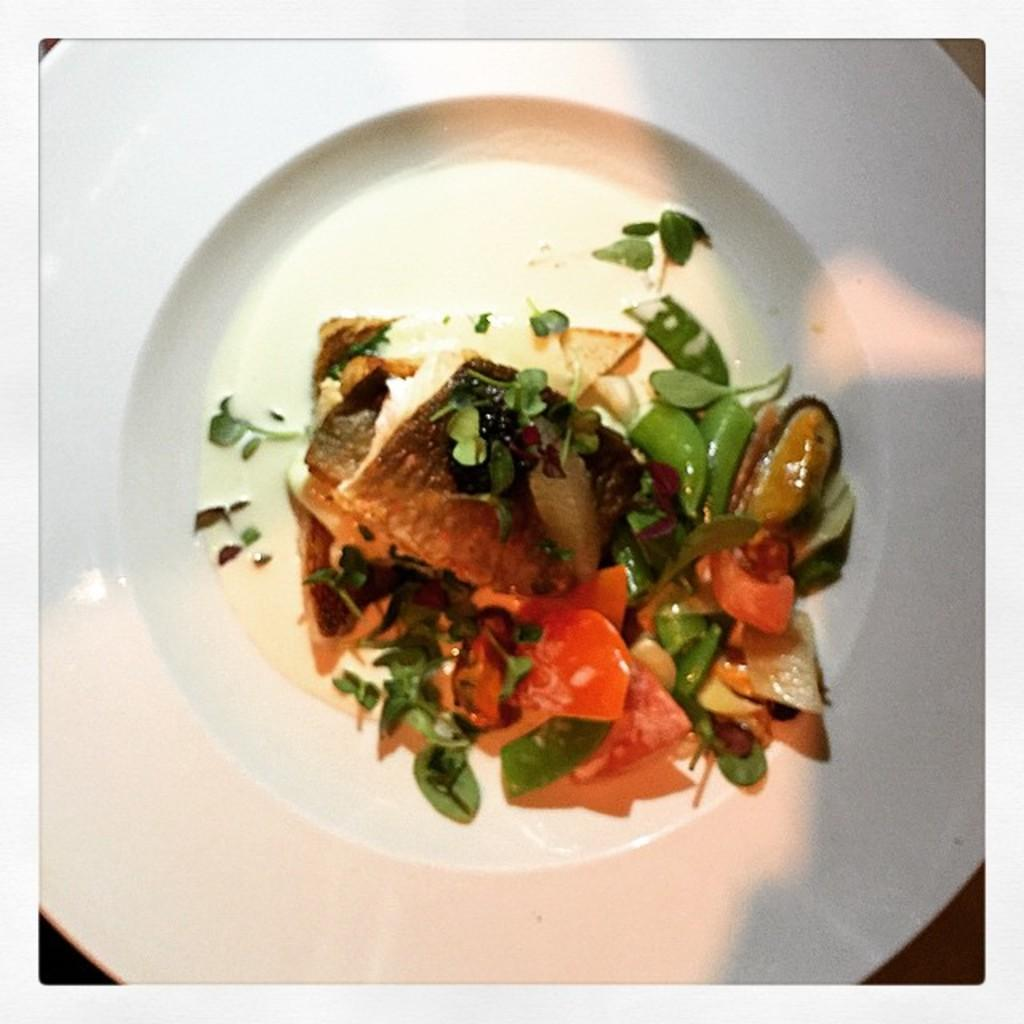What is the main subject of the image? There is a food item in the image. Can you describe the plate on which the food item is placed? The food item is on a white color plate. What type of toe can be seen in the image? There are no toes present in the image; it features a food item on a white color plate. What type of ticket is visible in the image? There are no tickets present in the image; it features a food item on a white color plate. 